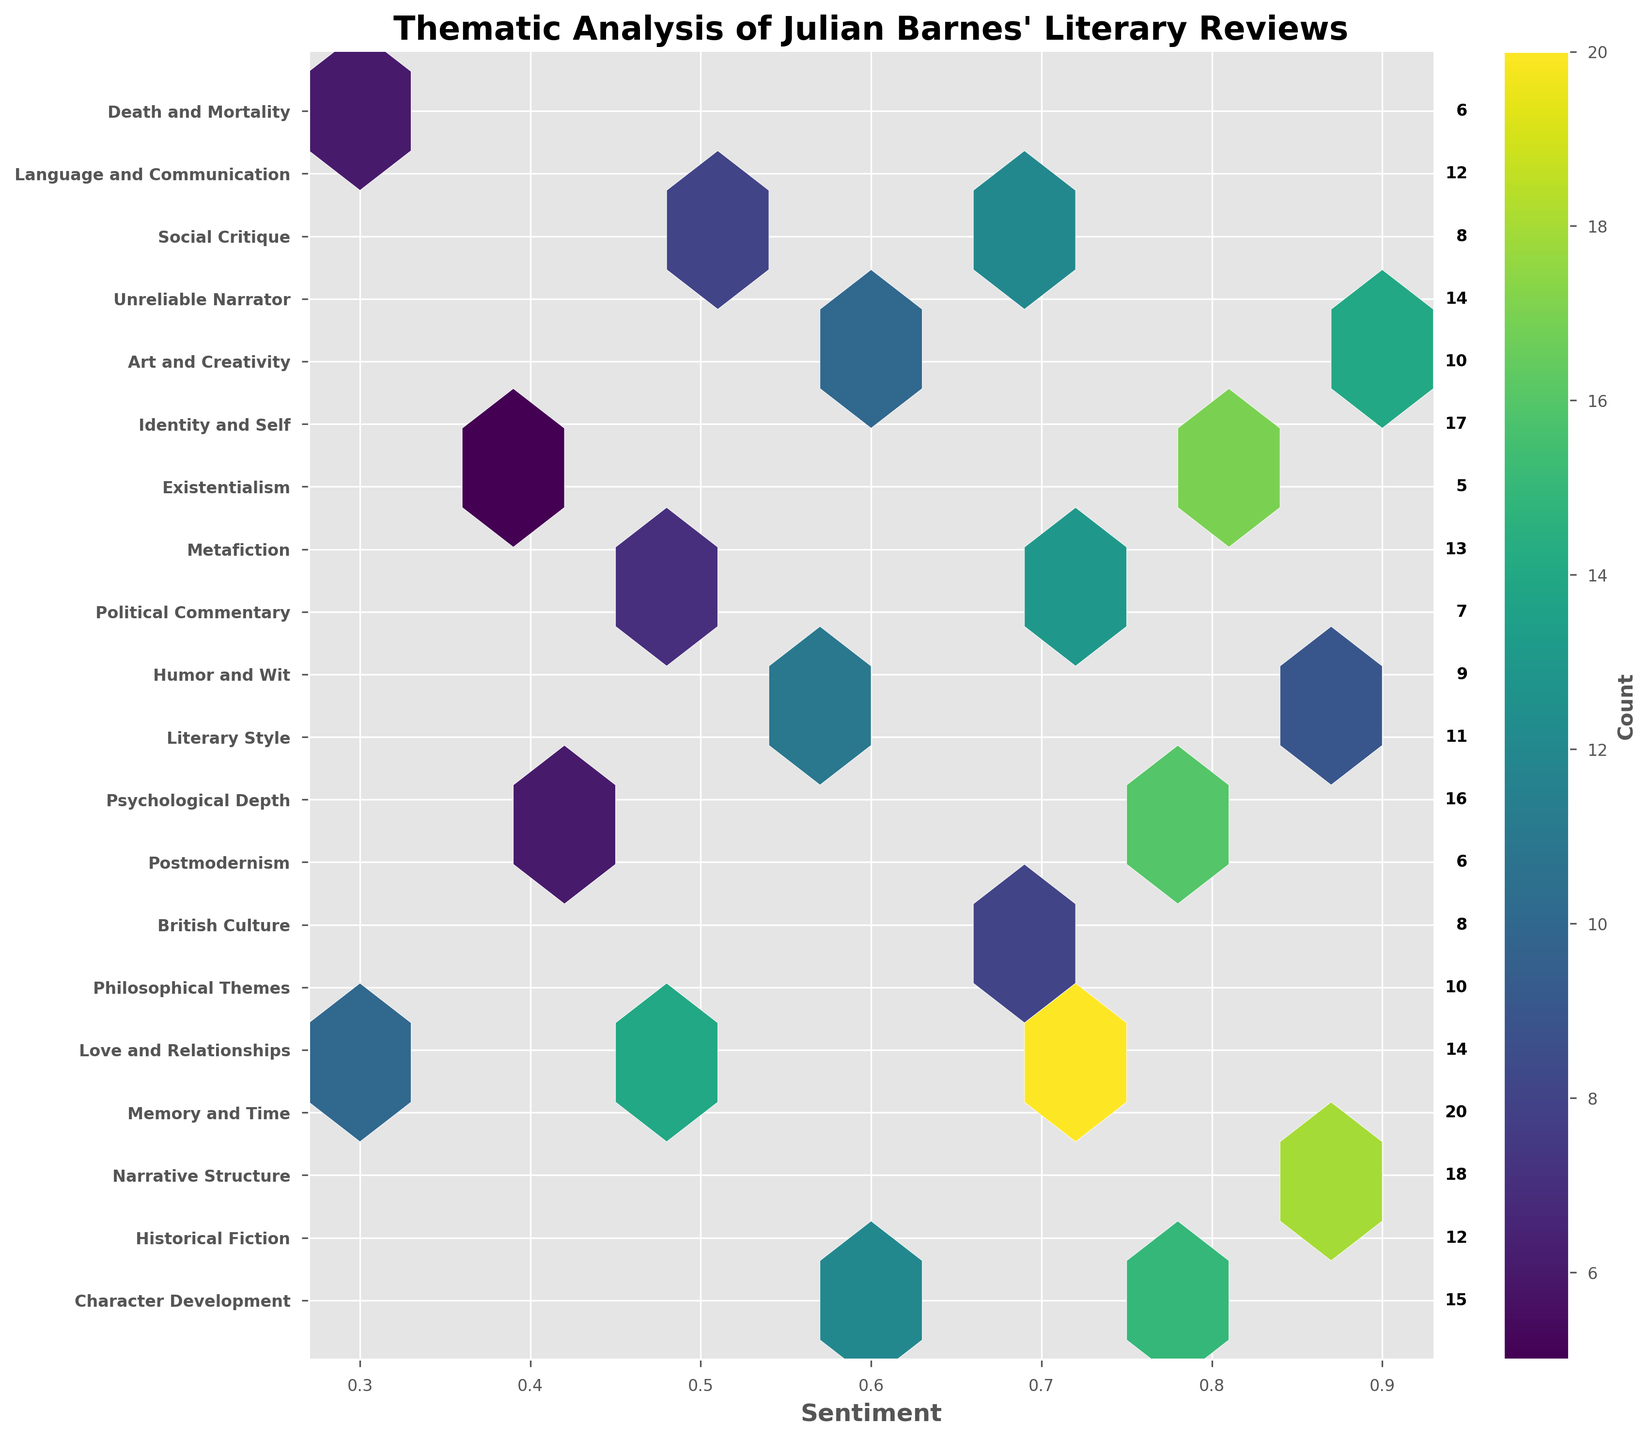What is the title of the figure? The title is displayed at the top of the figure and summarizes the content shown. The title is "Thematic Analysis of Julian Barnes' Literary Reviews."
Answer: Thematic Analysis of Julian Barnes' Literary Reviews What axis represents sentiment? The sentiment is represented on the horizontal axis, annotated with the label 'Sentiment.'
Answer: Horizontal axis Which topic has the highest count? To determine this, look for the largest value among the counts next to each topic label on the vertical axis. The topic with the highest count is "Memory and Time" with a count of 20.
Answer: Memory and Time How many topics have a sentiment greater than 0.7? To find this, identify the number of points where the sentiment value, on the horizontal axis, is greater than 0.7. The sentiment values greater than 0.7 are 0.8 and 0.9, which correspond to six topics in total.
Answer: Six What range of count values is represented in the color bar? The color bar indicates the range of counts. The ticks at either end of the color bar show the lowest and highest values. The range goes from 5 to 20 as shown by the edges of the color bar.
Answer: 5 to 20 Which topic is placed midway between "Historical Fiction" and "Philosophical Themes" in terms of sentiment? Two topics, "Narrative Structure" and "Memory and Time," are present between "Historical Fiction" (sentiment=0.6) and "Philosophical Themes" (sentiment=0.3). The lower count (Narrative Structure) should be checked, but similarities in position favor "Memory and Time" being midway.
Answer: Memory and Time What is the sentiment value for "Social Critique"? Find "Social Critique" along the vertical axis and trace horizontally to the sentiment value intersections. It shows 0.5.
Answer: 0.5 Which sentiment value is most frequently illustrated in the figure based on the number of topics listed? Count the occurrence of each unique sentiment value. The value 0.7 is found four times which is the most frequent.
Answer: 0.7 What is the average count for topics with a sentiment of 0.9? Add the counts for all topics with a sentiment of 0.9: Narrative Structure (18), Humor and Wit (9), Unreliable Narrator (14). The average is calculated as (18 + 9 + 14) / 3 = 41 / 3 ≈ 13.67.
Answer: ~13.67 